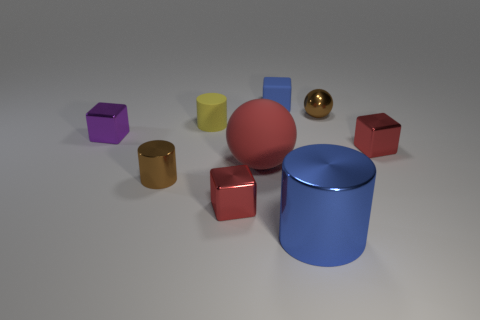Subtract all small cylinders. How many cylinders are left? 1 Subtract all red spheres. How many spheres are left? 1 Add 1 red matte spheres. How many objects exist? 10 Subtract 3 cubes. How many cubes are left? 1 Subtract all yellow spheres. How many red cubes are left? 2 Subtract all spheres. How many objects are left? 7 Subtract 1 blue cylinders. How many objects are left? 8 Subtract all cyan spheres. Subtract all green cylinders. How many spheres are left? 2 Subtract all large purple metal balls. Subtract all small purple cubes. How many objects are left? 8 Add 8 tiny blue matte cubes. How many tiny blue matte cubes are left? 9 